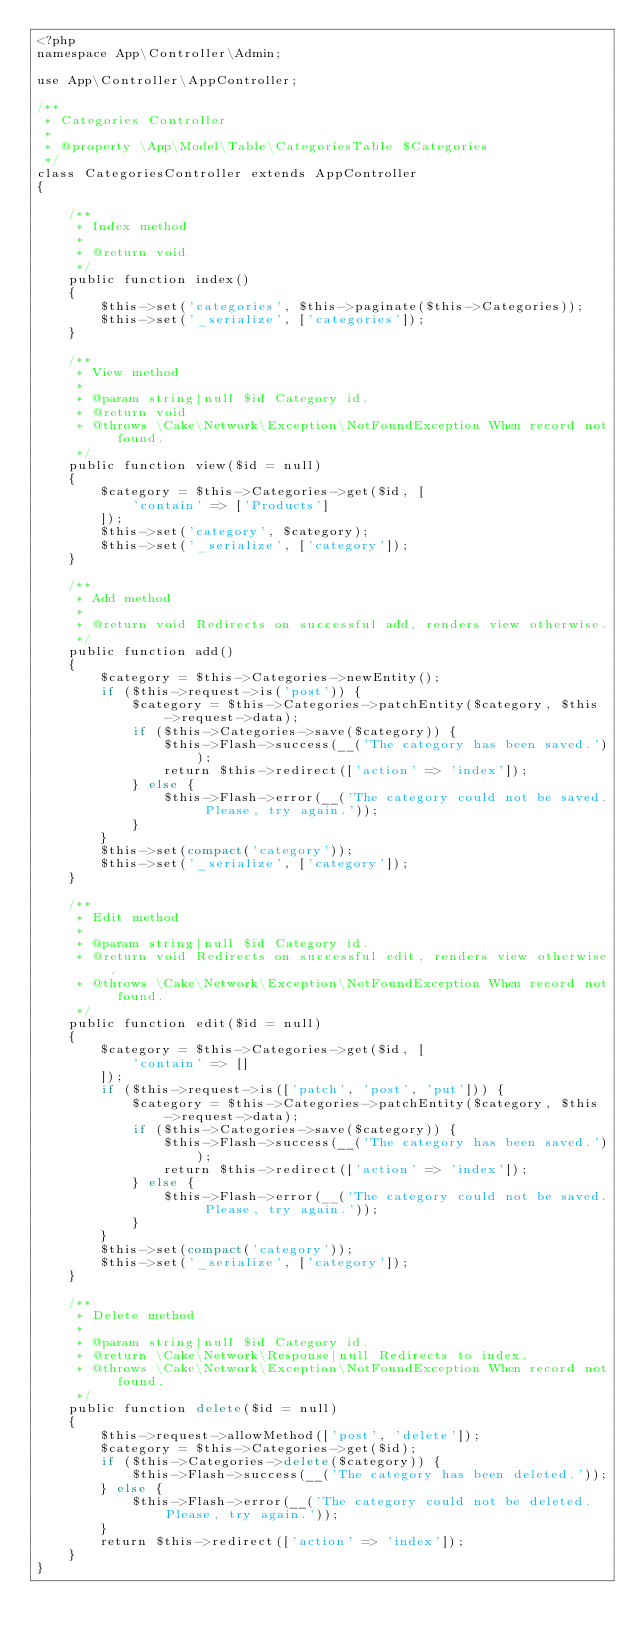<code> <loc_0><loc_0><loc_500><loc_500><_PHP_><?php
namespace App\Controller\Admin;

use App\Controller\AppController;

/**
 * Categories Controller
 *
 * @property \App\Model\Table\CategoriesTable $Categories
 */
class CategoriesController extends AppController
{

    /**
     * Index method
     *
     * @return void
     */
    public function index()
    {
        $this->set('categories', $this->paginate($this->Categories));
        $this->set('_serialize', ['categories']);
    }

    /**
     * View method
     *
     * @param string|null $id Category id.
     * @return void
     * @throws \Cake\Network\Exception\NotFoundException When record not found.
     */
    public function view($id = null)
    {
        $category = $this->Categories->get($id, [
            'contain' => ['Products']
        ]);
        $this->set('category', $category);
        $this->set('_serialize', ['category']);
    }

    /**
     * Add method
     *
     * @return void Redirects on successful add, renders view otherwise.
     */
    public function add()
    {
        $category = $this->Categories->newEntity();
        if ($this->request->is('post')) {
            $category = $this->Categories->patchEntity($category, $this->request->data);
            if ($this->Categories->save($category)) {
                $this->Flash->success(__('The category has been saved.'));
                return $this->redirect(['action' => 'index']);
            } else {
                $this->Flash->error(__('The category could not be saved. Please, try again.'));
            }
        }
        $this->set(compact('category'));
        $this->set('_serialize', ['category']);
    }

    /**
     * Edit method
     *
     * @param string|null $id Category id.
     * @return void Redirects on successful edit, renders view otherwise.
     * @throws \Cake\Network\Exception\NotFoundException When record not found.
     */
    public function edit($id = null)
    {
        $category = $this->Categories->get($id, [
            'contain' => []
        ]);
        if ($this->request->is(['patch', 'post', 'put'])) {
            $category = $this->Categories->patchEntity($category, $this->request->data);
            if ($this->Categories->save($category)) {
                $this->Flash->success(__('The category has been saved.'));
                return $this->redirect(['action' => 'index']);
            } else {
                $this->Flash->error(__('The category could not be saved. Please, try again.'));
            }
        }
        $this->set(compact('category'));
        $this->set('_serialize', ['category']);
    }

    /**
     * Delete method
     *
     * @param string|null $id Category id.
     * @return \Cake\Network\Response|null Redirects to index.
     * @throws \Cake\Network\Exception\NotFoundException When record not found.
     */
    public function delete($id = null)
    {
        $this->request->allowMethod(['post', 'delete']);
        $category = $this->Categories->get($id);
        if ($this->Categories->delete($category)) {
            $this->Flash->success(__('The category has been deleted.'));
        } else {
            $this->Flash->error(__('The category could not be deleted. Please, try again.'));
        }
        return $this->redirect(['action' => 'index']);
    }
}
</code> 